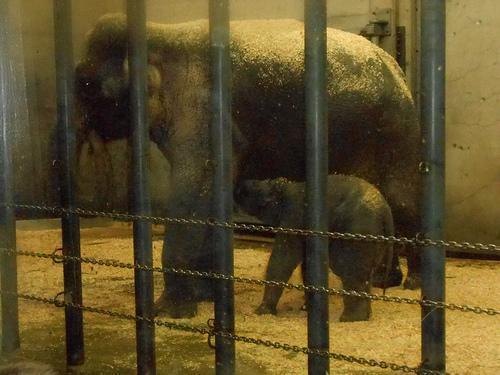How many elephants?
Give a very brief answer. 2. How many chains run across the bars?
Give a very brief answer. 3. How many iron bars are shown?
Give a very brief answer. 6. How many of the elephants are under another elephant?
Give a very brief answer. 1. 